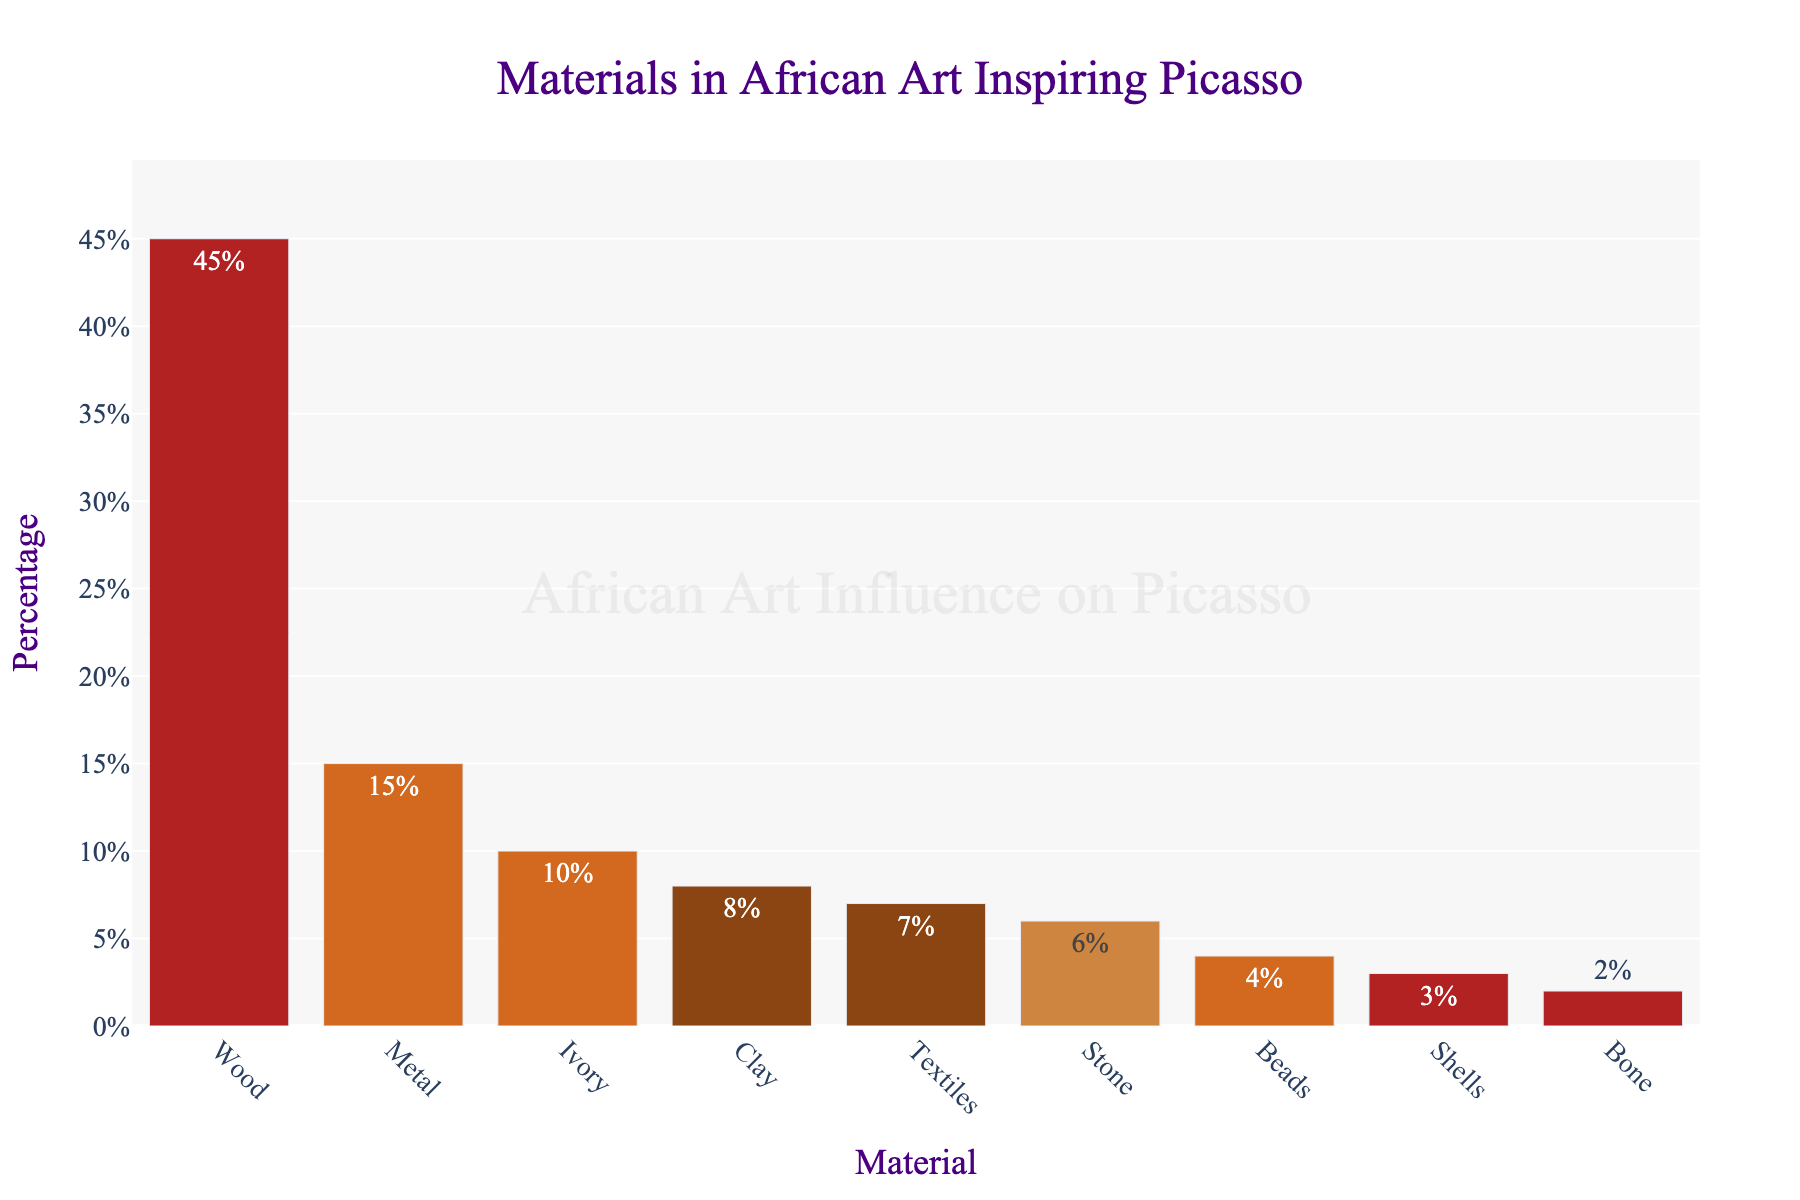What's the most common material used in African Art that inspired Picasso? The bar chart shows that the material with the highest percentage is placed at the top of the bar chart. The bar for Wood is the tallest, with a percentage of 45%. Thus, wood is the most common material.
Answer: Wood Which material has the second lowest percentage? The bars are sorted such that the material with the lowest percentage is at the bottom of the bar chart. The second lowest percentage is represented by the bar just above Bone. Shells is represented by this bar at 3%.
Answer: Shells What is the combined percentage of Wooden and Metal materials? The chart shows that the percentage for Wood is 45% and for Metal is 15%. Adding these two percentages together gives 60%.
Answer: 60% Which materials have a percentage greater than 10%? From the bar chart, Wood (45%), Metal (15%), and Ivory (10%) are shown. Only Wood and Metal have values greater than 10%.
Answer: Wood, Metal How much higher is the percentage of Stone compared to Bone? The chart indicates that the percentage for Stone is 6% and for Bone is 2%. Subtracting 2% from 6% gives a difference of 4%.
Answer: 4% What materials have approximately equal percentages? Examining the chart, we see the bars for Clay (8%) and Textiles (7%) are nearly the same, as well as Beads (4%) and Shells (3%). This suggests that these materials have approximately equal percentages relative to each other.
Answer: Clay and Textiles, Beads and Shells Which bar is the shortest and what percentage does it represent? The shortest bar among those depicted in the figure belongs to Bone, which represents a percentage of 2%.
Answer: Bone, 2% Arrange the materials in descending order based on their percentage. The chart shows materials in a descending sequence from top to bottom as follows: Wood (45%), Metal (15%), Ivory (10%), Clay (8%), Textiles (7%), Stone (6%), Beads (4%), Shells (3%), Bone (2%).
Answer: Wood, Metal, Ivory, Clay, Textiles, Stone, Beads, Shells, Bone What is the average percentage of Metal, Ivory, and Stone materials? According to the chart, Metal has a percentage of 15%, Ivory 10%, and Stone 6%. Summing these gives 31%. Dividing by 3 (number of materials) results in an average of approximately 10.33%.
Answer: 10.33% 